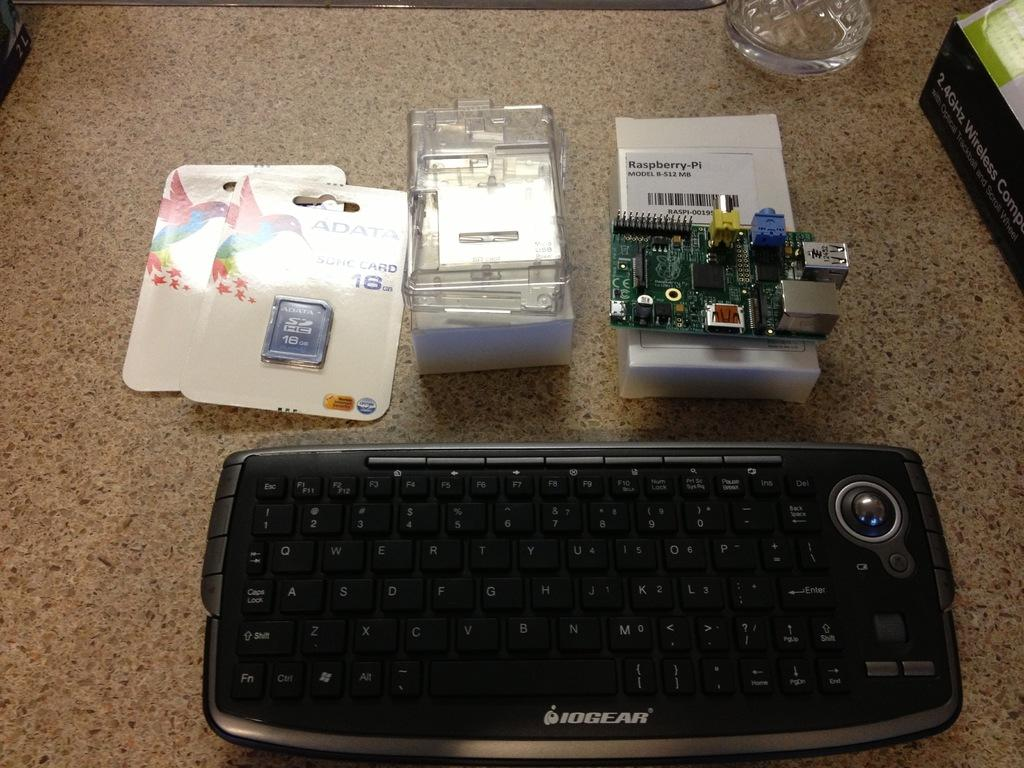<image>
Give a short and clear explanation of the subsequent image. IOGEAR laptop next to some computer parts on a table. 